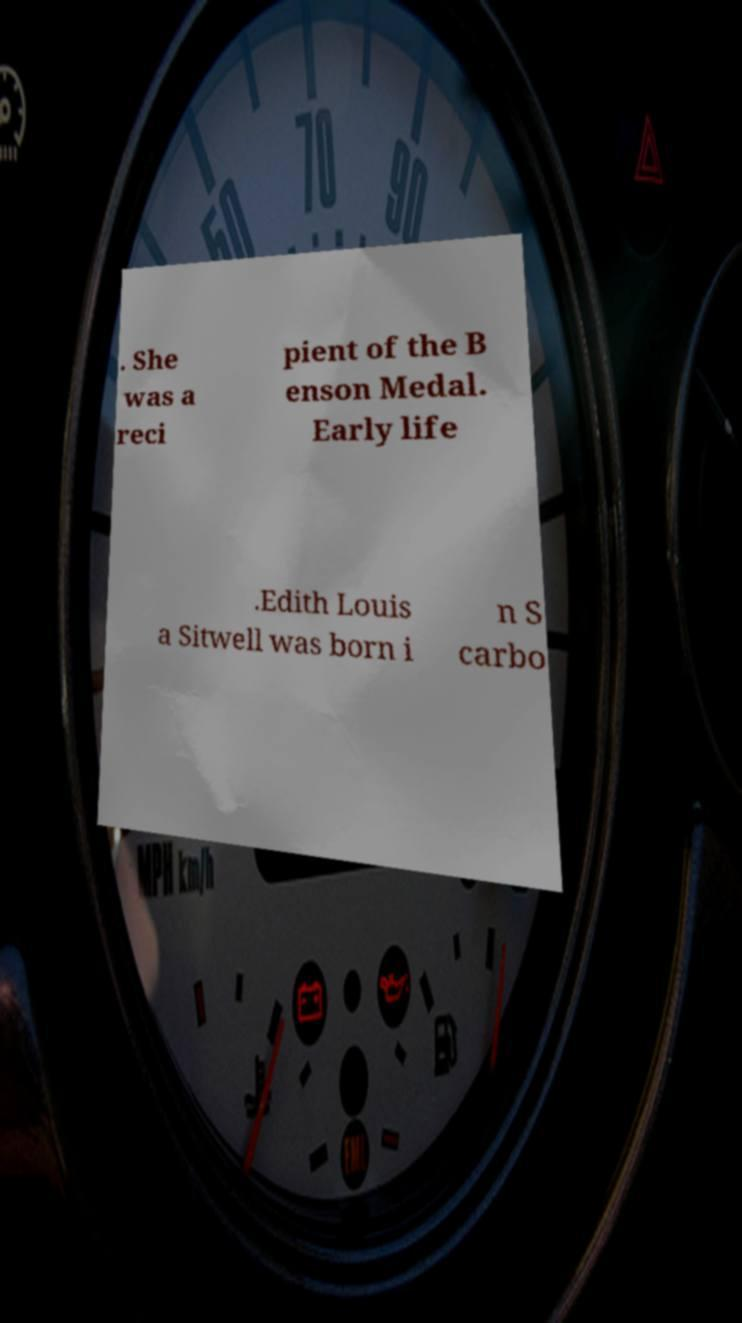Please read and relay the text visible in this image. What does it say? . She was a reci pient of the B enson Medal. Early life .Edith Louis a Sitwell was born i n S carbo 